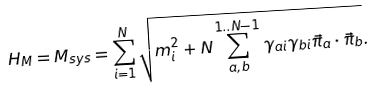Convert formula to latex. <formula><loc_0><loc_0><loc_500><loc_500>H _ { M } = M _ { s y s } = \sum _ { i = 1 } ^ { N } \sqrt { m ^ { 2 } _ { i } + N \sum _ { a , b } ^ { 1 . . N - 1 } \gamma _ { a i } \gamma _ { b i } { \vec { \pi } } _ { a } \cdot { \vec { \pi } } _ { b } } .</formula> 